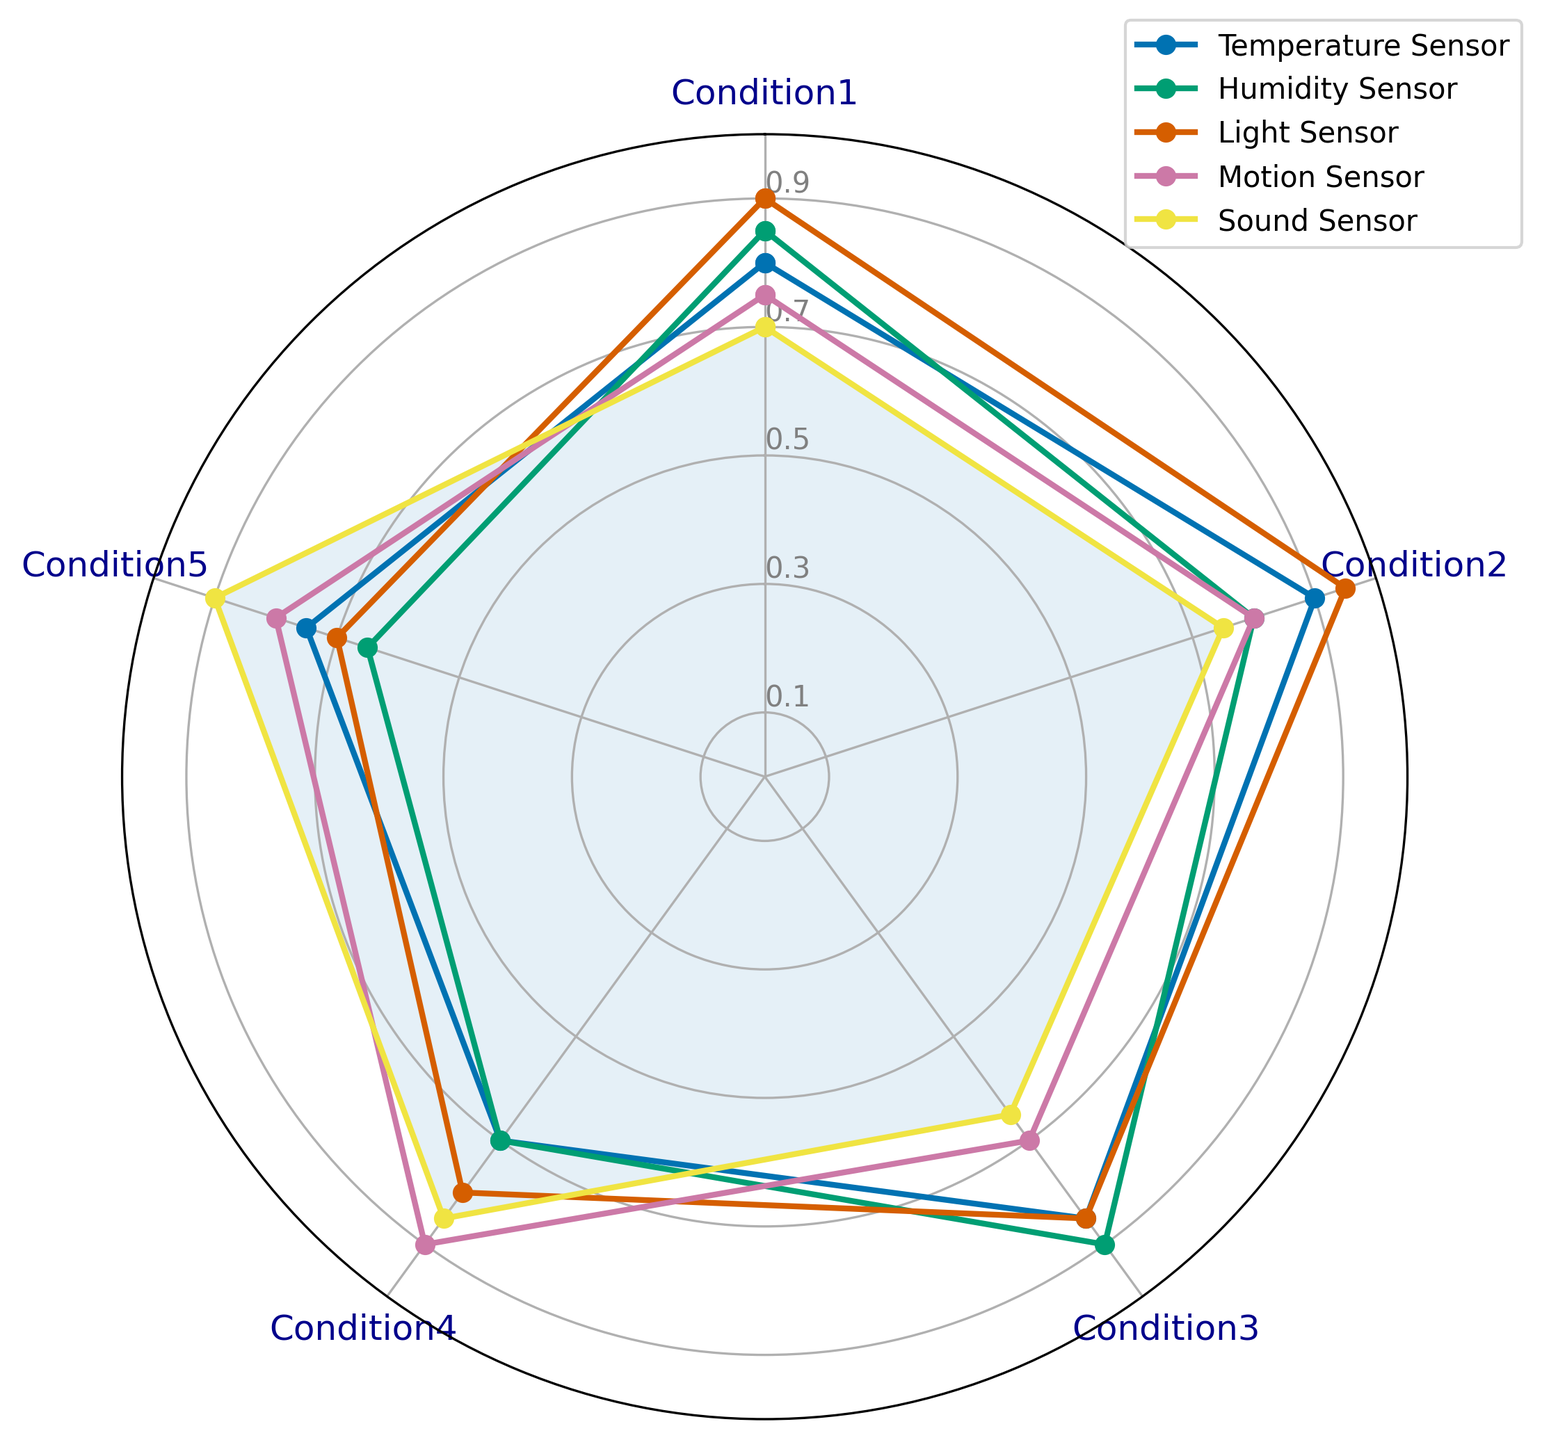What is the highest reliability score for the Temperature Sensor across all conditions? By looking at the plot, identify the highest point for the Temperature Sensor's line across all five conditions. The highest point represents the maximum reliability score.
Answer: 0.9 Which sensor has the lowest overall reliability in Condition 5? Check the values for Condition 5 across all sensors and identify the lowest score.
Answer: Humidity Sensor How does the reliability of the Motion Sensor in Condition 4 compare to the Light Sensor in the same condition? Locate the reliability scores for both the Motion Sensor and Light Sensor in Condition 4 on the radar chart. Compare the two values to determine which is higher.
Answer: The reliability of the Motion Sensor is higher What is the average reliability score of the Sound Sensor across all conditions? Sum the reliability scores for the Sound Sensor across all conditions and divide by the number of conditions (5).
Answer: 0.77 Between Condition 2 and Condition 3, which one has better overall reliability scores? Calculate the average reliability score for all sensors in Condition 2 and Condition 3 separately and compare the two average scores.
Answer: Condition 2 Which sensor shows the most variation in reliability scores across all conditions? Calculate the range of reliability scores (difference between maximum and minimum) for each sensor and determine which sensor has the highest variation.
Answer: Sound Sensor What is the median reliability score for the Humidity Sensor? Organize the reliability scores for the Humidity Sensor in ascending order and identify the middle value.
Answer: 0.8 For Condition 1, which two sensors have the closest reliability scores? Compare the reliability scores for all sensors in Condition 1 and identify the two sensors with the smallest difference in scores.
Answer: Motion Sensor and Sound Sensor Which sensor's reliability is below 0.8 in three or more conditions? Identify the sensors whose reliability scores fall below 0.8 in at least three different conditions.
Answer: Sound Sensor 